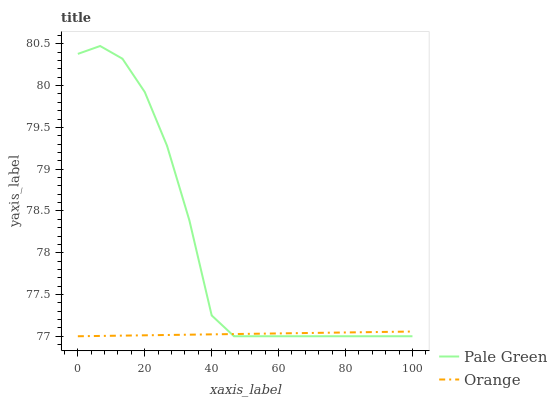Does Orange have the minimum area under the curve?
Answer yes or no. Yes. Does Pale Green have the maximum area under the curve?
Answer yes or no. Yes. Does Pale Green have the minimum area under the curve?
Answer yes or no. No. Is Orange the smoothest?
Answer yes or no. Yes. Is Pale Green the roughest?
Answer yes or no. Yes. Is Pale Green the smoothest?
Answer yes or no. No. Does Orange have the lowest value?
Answer yes or no. Yes. Does Pale Green have the highest value?
Answer yes or no. Yes. Does Pale Green intersect Orange?
Answer yes or no. Yes. Is Pale Green less than Orange?
Answer yes or no. No. Is Pale Green greater than Orange?
Answer yes or no. No. 